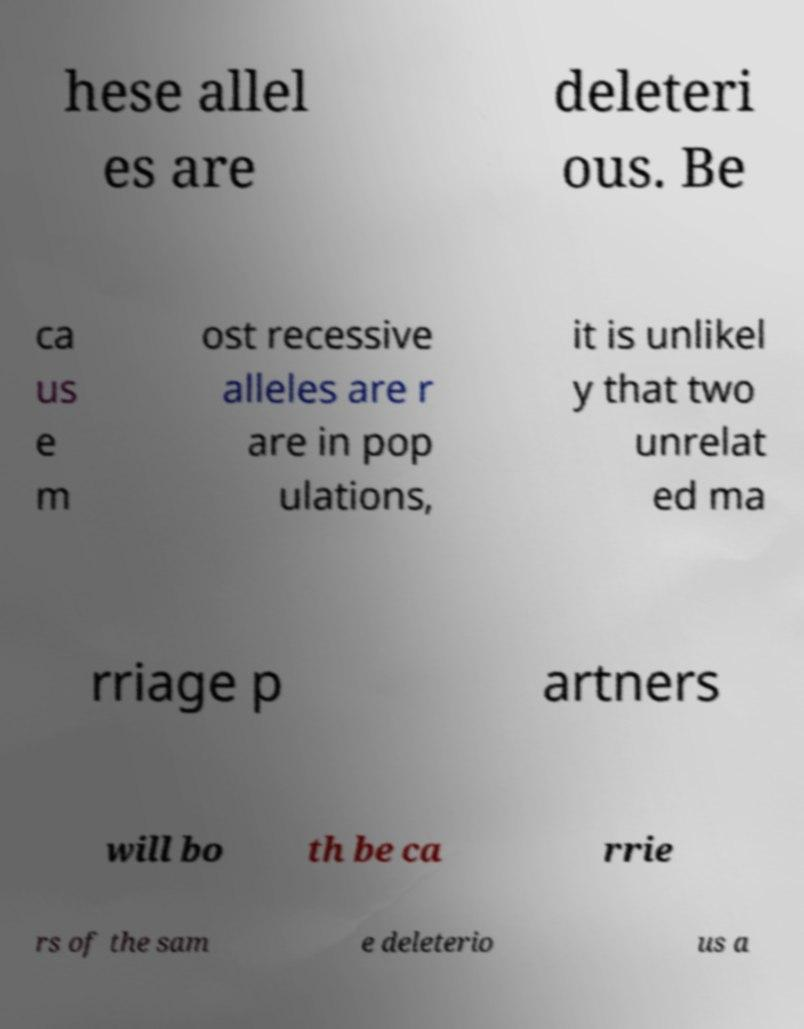Could you assist in decoding the text presented in this image and type it out clearly? hese allel es are deleteri ous. Be ca us e m ost recessive alleles are r are in pop ulations, it is unlikel y that two unrelat ed ma rriage p artners will bo th be ca rrie rs of the sam e deleterio us a 